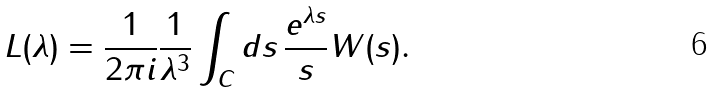<formula> <loc_0><loc_0><loc_500><loc_500>L ( \lambda ) = \frac { 1 } { 2 \pi i } \frac { 1 } { \lambda ^ { 3 } } \int _ { C } d s \, \frac { e ^ { \lambda s } } { s } W ( s ) .</formula> 